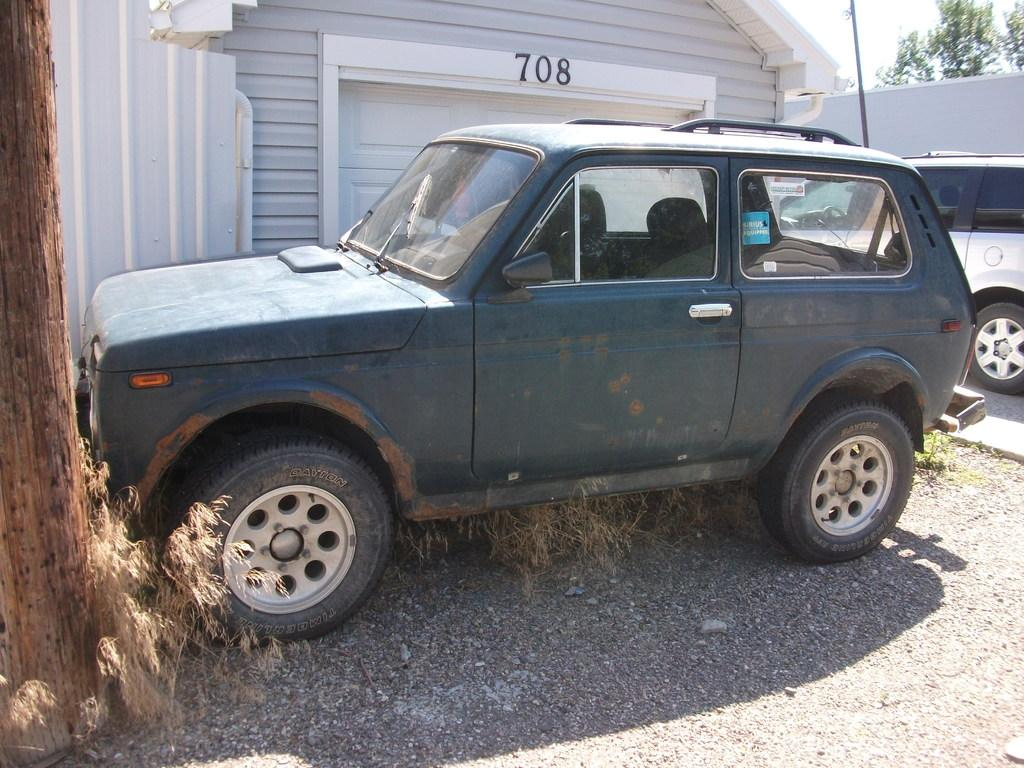<image>
Describe the image concisely. a house that says 708 on the front of it 